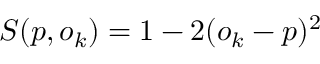<formula> <loc_0><loc_0><loc_500><loc_500>S ( p , o _ { k } ) = 1 - 2 ( o _ { k } - p ) ^ { 2 }</formula> 